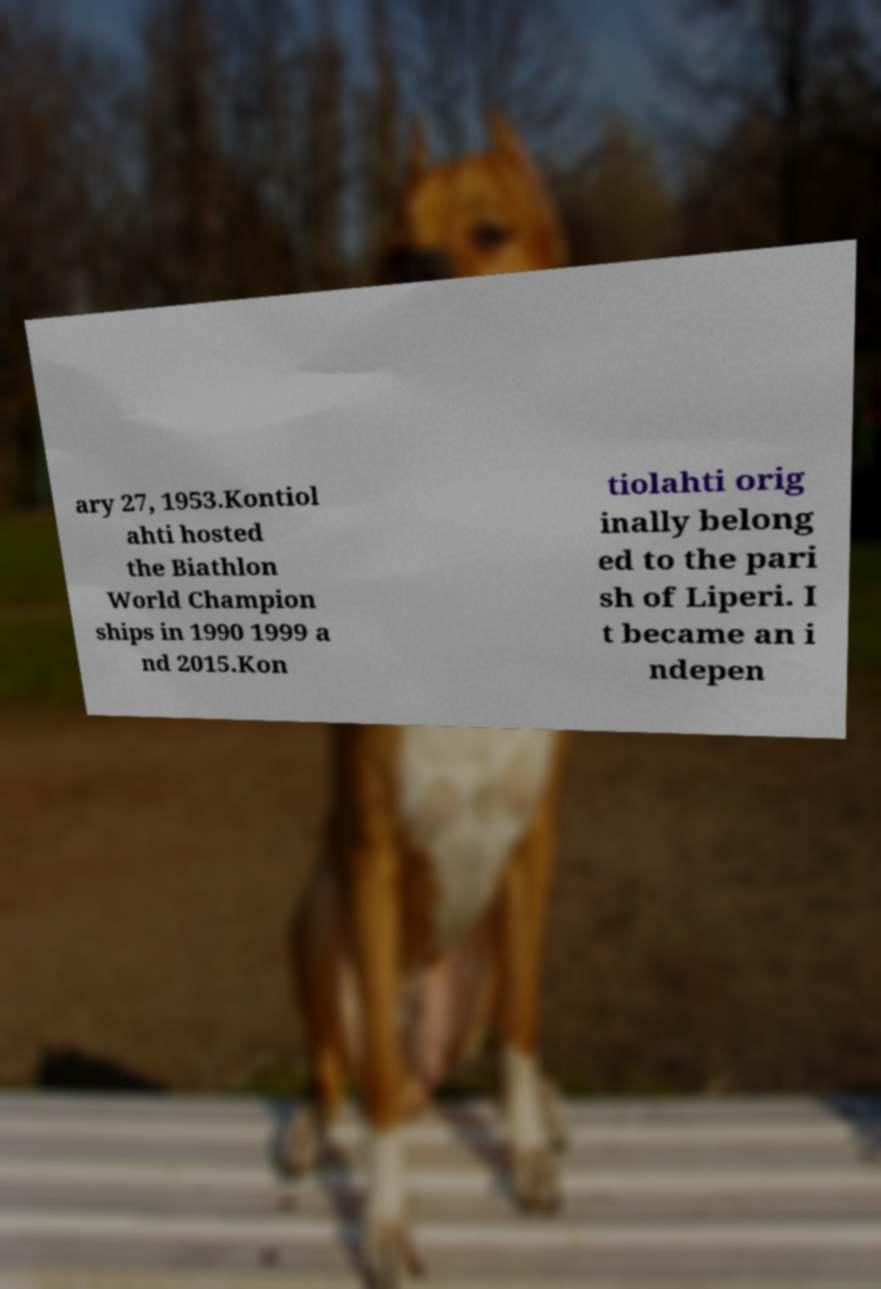Could you assist in decoding the text presented in this image and type it out clearly? ary 27, 1953.Kontiol ahti hosted the Biathlon World Champion ships in 1990 1999 a nd 2015.Kon tiolahti orig inally belong ed to the pari sh of Liperi. I t became an i ndepen 